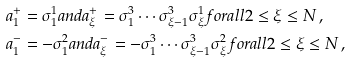<formula> <loc_0><loc_0><loc_500><loc_500>& a _ { 1 } ^ { + } = \sigma ^ { 1 } _ { 1 } a n d a _ { \xi } ^ { + } = \sigma _ { 1 } ^ { 3 } \cdots \sigma _ { \xi - 1 } ^ { 3 } \sigma ^ { 1 } _ { \xi } f o r a l l 2 \leq \xi \leq N \, , \\ & a _ { 1 } ^ { - } = - \sigma _ { 1 } ^ { 2 } a n d a _ { \xi } ^ { - } = - \sigma _ { 1 } ^ { 3 } \cdots \sigma _ { \xi - 1 } ^ { 3 } \sigma ^ { 2 } _ { \xi } f o r a l l 2 \leq \xi \leq N \, ,</formula> 